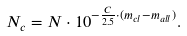<formula> <loc_0><loc_0><loc_500><loc_500>N _ { c } = N \cdot 1 0 ^ { - \frac { C } { 2 . 5 } \cdot ( m _ { c l } - m _ { a l l } ) } .</formula> 